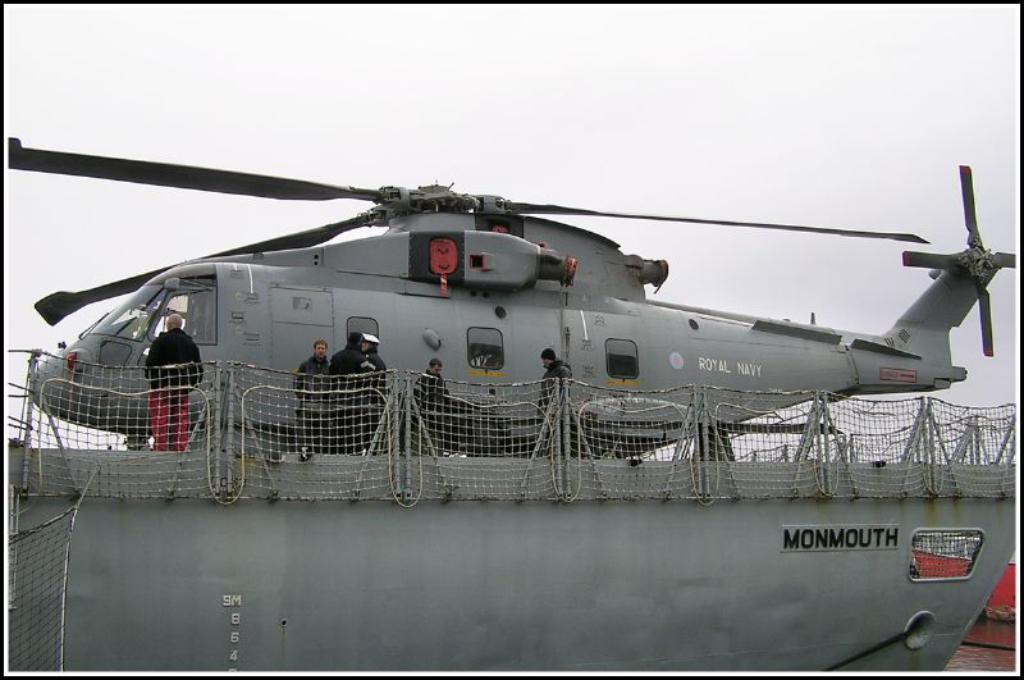What type of structure can be seen in the image? There is a fence in the image. What else is visible in the image besides the fence? There is a plane and people present in the image. What can be seen in the sky in the image? The sky is visible in the image. What type of nut is being used to hold the fence together in the image? There is no mention of nuts being used to hold the fence together in the image. What type of plants can be seen growing near the fence in the image? There is no mention of plants in the image. 